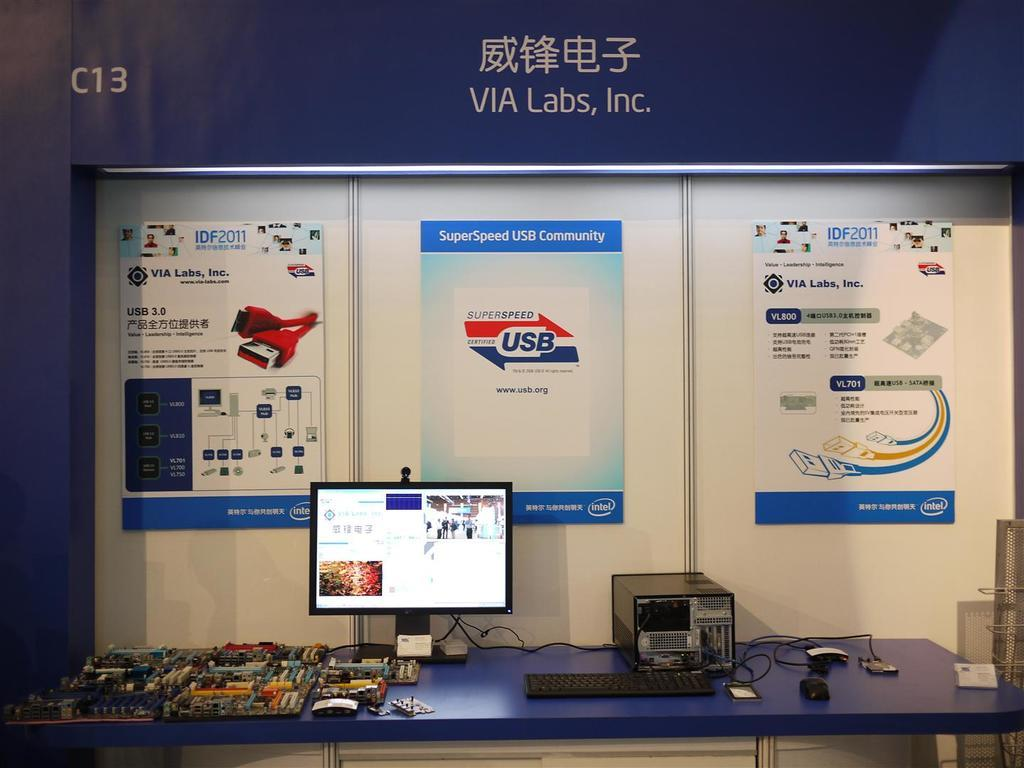<image>
Present a compact description of the photo's key features. Via Labs, Inc. has a display with electronic equipment on a table 